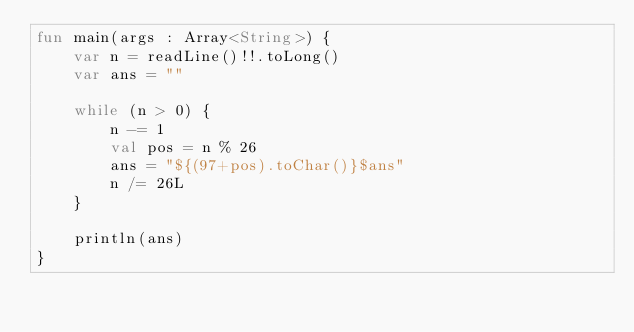Convert code to text. <code><loc_0><loc_0><loc_500><loc_500><_Kotlin_>fun main(args : Array<String>) {
    var n = readLine()!!.toLong()
    var ans = ""

    while (n > 0) {
        n -= 1
        val pos = n % 26
        ans = "${(97+pos).toChar()}$ans"
        n /= 26L
    }

    println(ans)
}</code> 